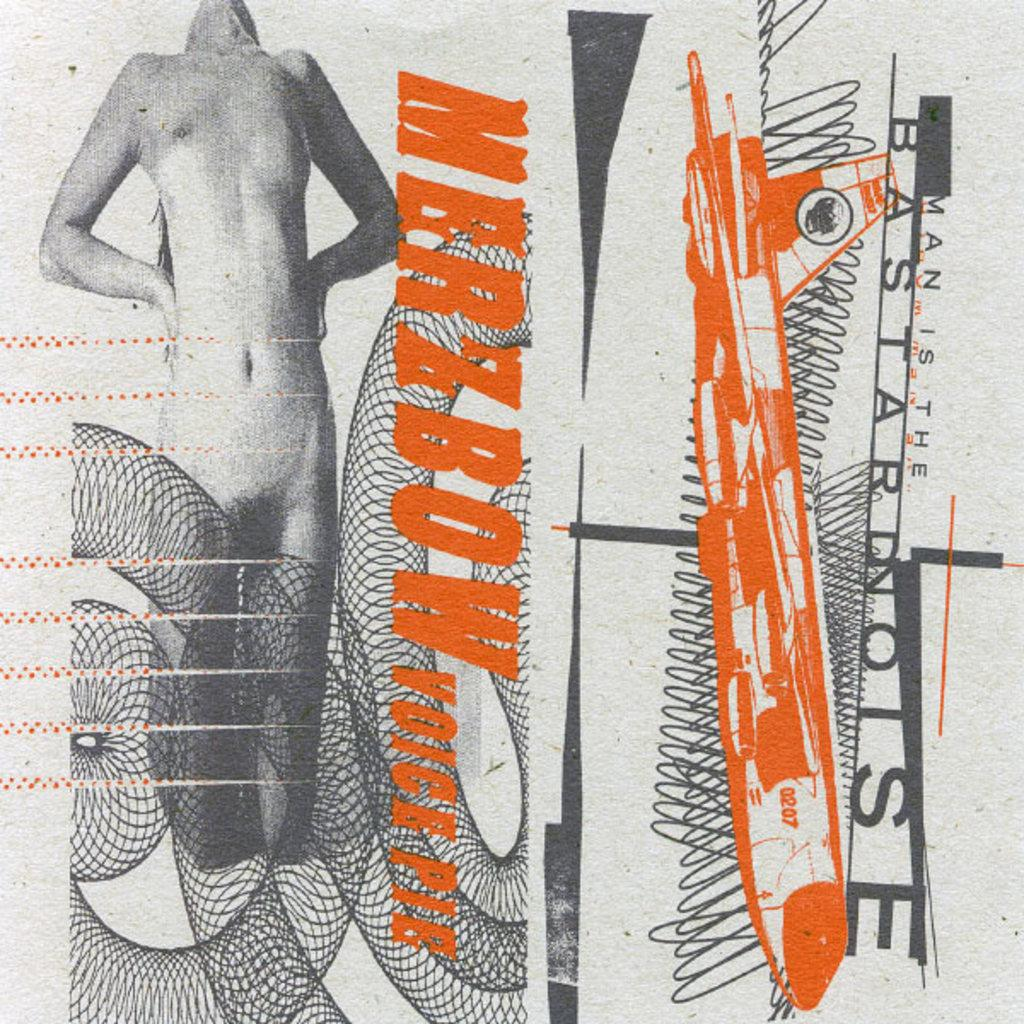Who is the main subject in the image? There is a woman in the image. Where is the woman located in the image? The woman is on the left side of the image. What else can be seen in the image besides the woman? There is an aircraft in the image. Where is the aircraft located in the image? The aircraft is on the right side of the image. Is there any text or writing present in the image? Yes, there is text or writing on the image. Can you tell me how many times the woman combed her hair in the image? There is no information about the woman combing her hair in the image. What type of bite can be seen on the aircraft in the image? There is no bite visible on the aircraft in the image. 